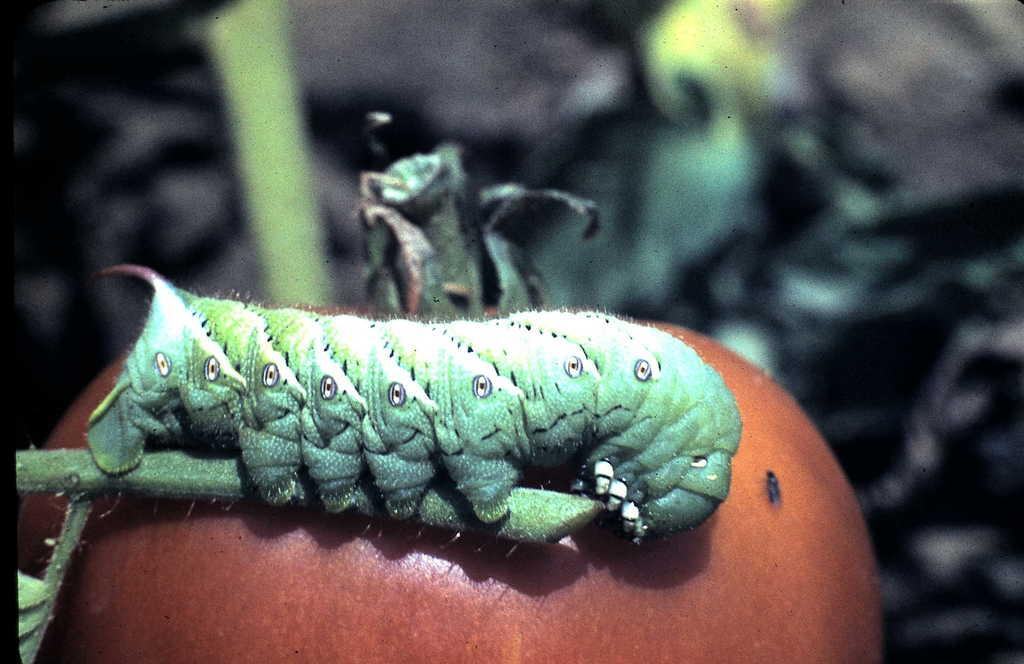What type of creature can be seen in the image? There is a worm visible in the image. What might the worm be on or near? The worm may be on a vegetable. How would you describe the background of the image? The background of the image is blurry. Can you identify any objects in the background? Yes, there are objects visible in the background. What type of bat is flying in the image? There is no bat present in the image; it features a worm that may be on a vegetable. What is the thing that the worm is doing in the image? The worm is not performing any action that can be described as "doing" something; it is simply visible on or near a vegetable. 